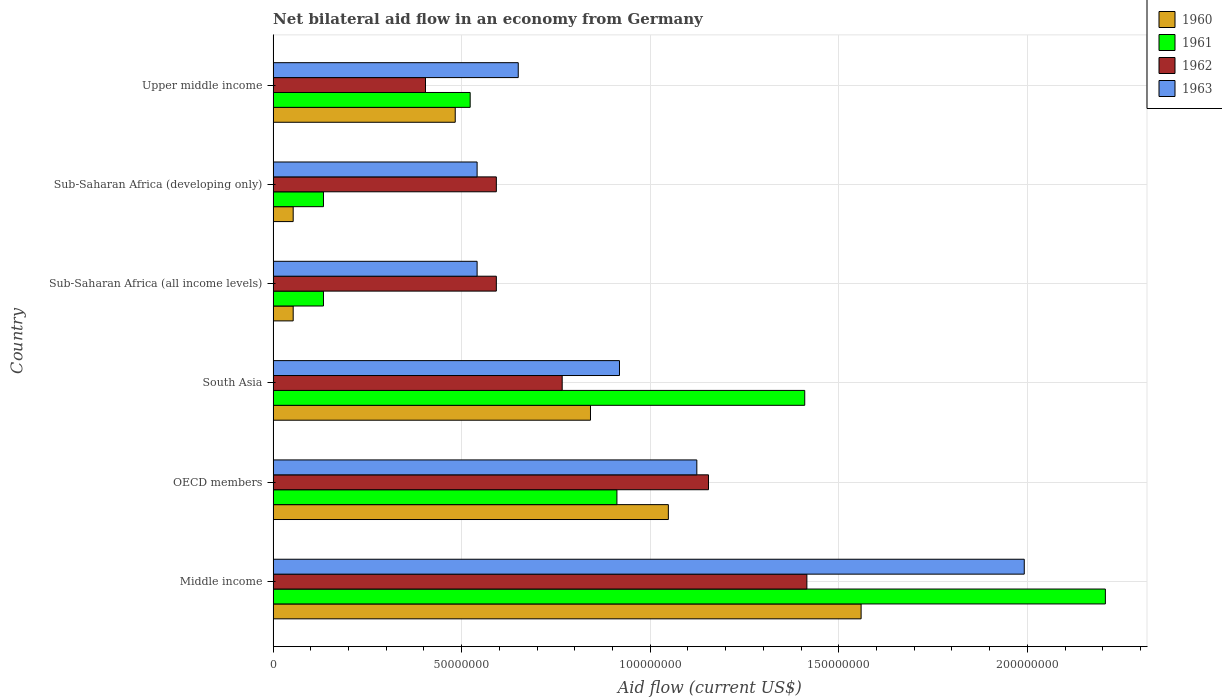How many different coloured bars are there?
Your response must be concise. 4. Are the number of bars per tick equal to the number of legend labels?
Ensure brevity in your answer.  Yes. Are the number of bars on each tick of the Y-axis equal?
Your answer should be compact. Yes. What is the net bilateral aid flow in 1963 in Upper middle income?
Give a very brief answer. 6.50e+07. Across all countries, what is the maximum net bilateral aid flow in 1960?
Your answer should be compact. 1.56e+08. Across all countries, what is the minimum net bilateral aid flow in 1960?
Ensure brevity in your answer.  5.32e+06. In which country was the net bilateral aid flow in 1960 maximum?
Make the answer very short. Middle income. In which country was the net bilateral aid flow in 1961 minimum?
Your answer should be compact. Sub-Saharan Africa (all income levels). What is the total net bilateral aid flow in 1962 in the graph?
Offer a very short reply. 4.92e+08. What is the difference between the net bilateral aid flow in 1960 in Sub-Saharan Africa (all income levels) and that in Sub-Saharan Africa (developing only)?
Offer a very short reply. 0. What is the difference between the net bilateral aid flow in 1963 in Sub-Saharan Africa (developing only) and the net bilateral aid flow in 1962 in Upper middle income?
Offer a very short reply. 1.37e+07. What is the average net bilateral aid flow in 1961 per country?
Make the answer very short. 8.86e+07. What is the difference between the net bilateral aid flow in 1962 and net bilateral aid flow in 1961 in OECD members?
Offer a very short reply. 2.43e+07. In how many countries, is the net bilateral aid flow in 1963 greater than 20000000 US$?
Provide a short and direct response. 6. What is the ratio of the net bilateral aid flow in 1962 in Middle income to that in Upper middle income?
Your answer should be very brief. 3.5. What is the difference between the highest and the second highest net bilateral aid flow in 1962?
Your answer should be very brief. 2.61e+07. What is the difference between the highest and the lowest net bilateral aid flow in 1960?
Your answer should be compact. 1.51e+08. In how many countries, is the net bilateral aid flow in 1962 greater than the average net bilateral aid flow in 1962 taken over all countries?
Your answer should be very brief. 2. Is the sum of the net bilateral aid flow in 1961 in Sub-Saharan Africa (all income levels) and Upper middle income greater than the maximum net bilateral aid flow in 1962 across all countries?
Your answer should be very brief. No. What does the 4th bar from the bottom in OECD members represents?
Provide a short and direct response. 1963. What is the difference between two consecutive major ticks on the X-axis?
Make the answer very short. 5.00e+07. Does the graph contain any zero values?
Offer a very short reply. No. How are the legend labels stacked?
Give a very brief answer. Vertical. What is the title of the graph?
Your response must be concise. Net bilateral aid flow in an economy from Germany. Does "1988" appear as one of the legend labels in the graph?
Your response must be concise. No. What is the Aid flow (current US$) of 1960 in Middle income?
Your response must be concise. 1.56e+08. What is the Aid flow (current US$) of 1961 in Middle income?
Your response must be concise. 2.21e+08. What is the Aid flow (current US$) in 1962 in Middle income?
Keep it short and to the point. 1.42e+08. What is the Aid flow (current US$) in 1963 in Middle income?
Provide a short and direct response. 1.99e+08. What is the Aid flow (current US$) in 1960 in OECD members?
Ensure brevity in your answer.  1.05e+08. What is the Aid flow (current US$) in 1961 in OECD members?
Offer a terse response. 9.12e+07. What is the Aid flow (current US$) of 1962 in OECD members?
Ensure brevity in your answer.  1.15e+08. What is the Aid flow (current US$) of 1963 in OECD members?
Provide a short and direct response. 1.12e+08. What is the Aid flow (current US$) in 1960 in South Asia?
Provide a short and direct response. 8.42e+07. What is the Aid flow (current US$) of 1961 in South Asia?
Your answer should be very brief. 1.41e+08. What is the Aid flow (current US$) in 1962 in South Asia?
Your response must be concise. 7.66e+07. What is the Aid flow (current US$) of 1963 in South Asia?
Give a very brief answer. 9.18e+07. What is the Aid flow (current US$) of 1960 in Sub-Saharan Africa (all income levels)?
Provide a succinct answer. 5.32e+06. What is the Aid flow (current US$) in 1961 in Sub-Saharan Africa (all income levels)?
Give a very brief answer. 1.34e+07. What is the Aid flow (current US$) in 1962 in Sub-Saharan Africa (all income levels)?
Make the answer very short. 5.92e+07. What is the Aid flow (current US$) in 1963 in Sub-Saharan Africa (all income levels)?
Make the answer very short. 5.41e+07. What is the Aid flow (current US$) in 1960 in Sub-Saharan Africa (developing only)?
Make the answer very short. 5.32e+06. What is the Aid flow (current US$) of 1961 in Sub-Saharan Africa (developing only)?
Make the answer very short. 1.34e+07. What is the Aid flow (current US$) in 1962 in Sub-Saharan Africa (developing only)?
Make the answer very short. 5.92e+07. What is the Aid flow (current US$) in 1963 in Sub-Saharan Africa (developing only)?
Offer a terse response. 5.41e+07. What is the Aid flow (current US$) in 1960 in Upper middle income?
Give a very brief answer. 4.83e+07. What is the Aid flow (current US$) in 1961 in Upper middle income?
Give a very brief answer. 5.22e+07. What is the Aid flow (current US$) in 1962 in Upper middle income?
Your response must be concise. 4.04e+07. What is the Aid flow (current US$) of 1963 in Upper middle income?
Offer a very short reply. 6.50e+07. Across all countries, what is the maximum Aid flow (current US$) in 1960?
Make the answer very short. 1.56e+08. Across all countries, what is the maximum Aid flow (current US$) in 1961?
Your answer should be compact. 2.21e+08. Across all countries, what is the maximum Aid flow (current US$) in 1962?
Your answer should be compact. 1.42e+08. Across all countries, what is the maximum Aid flow (current US$) of 1963?
Your answer should be compact. 1.99e+08. Across all countries, what is the minimum Aid flow (current US$) in 1960?
Keep it short and to the point. 5.32e+06. Across all countries, what is the minimum Aid flow (current US$) in 1961?
Offer a very short reply. 1.34e+07. Across all countries, what is the minimum Aid flow (current US$) of 1962?
Make the answer very short. 4.04e+07. Across all countries, what is the minimum Aid flow (current US$) of 1963?
Give a very brief answer. 5.41e+07. What is the total Aid flow (current US$) in 1960 in the graph?
Your answer should be compact. 4.04e+08. What is the total Aid flow (current US$) of 1961 in the graph?
Your response must be concise. 5.32e+08. What is the total Aid flow (current US$) of 1962 in the graph?
Your answer should be compact. 4.92e+08. What is the total Aid flow (current US$) of 1963 in the graph?
Provide a succinct answer. 5.77e+08. What is the difference between the Aid flow (current US$) in 1960 in Middle income and that in OECD members?
Offer a very short reply. 5.11e+07. What is the difference between the Aid flow (current US$) in 1961 in Middle income and that in OECD members?
Your response must be concise. 1.30e+08. What is the difference between the Aid flow (current US$) of 1962 in Middle income and that in OECD members?
Give a very brief answer. 2.61e+07. What is the difference between the Aid flow (current US$) in 1963 in Middle income and that in OECD members?
Provide a succinct answer. 8.68e+07. What is the difference between the Aid flow (current US$) of 1960 in Middle income and that in South Asia?
Keep it short and to the point. 7.18e+07. What is the difference between the Aid flow (current US$) in 1961 in Middle income and that in South Asia?
Ensure brevity in your answer.  7.97e+07. What is the difference between the Aid flow (current US$) in 1962 in Middle income and that in South Asia?
Provide a succinct answer. 6.49e+07. What is the difference between the Aid flow (current US$) in 1963 in Middle income and that in South Asia?
Offer a terse response. 1.07e+08. What is the difference between the Aid flow (current US$) of 1960 in Middle income and that in Sub-Saharan Africa (all income levels)?
Ensure brevity in your answer.  1.51e+08. What is the difference between the Aid flow (current US$) of 1961 in Middle income and that in Sub-Saharan Africa (all income levels)?
Your answer should be compact. 2.07e+08. What is the difference between the Aid flow (current US$) of 1962 in Middle income and that in Sub-Saharan Africa (all income levels)?
Offer a terse response. 8.23e+07. What is the difference between the Aid flow (current US$) in 1963 in Middle income and that in Sub-Saharan Africa (all income levels)?
Offer a terse response. 1.45e+08. What is the difference between the Aid flow (current US$) of 1960 in Middle income and that in Sub-Saharan Africa (developing only)?
Offer a terse response. 1.51e+08. What is the difference between the Aid flow (current US$) in 1961 in Middle income and that in Sub-Saharan Africa (developing only)?
Offer a terse response. 2.07e+08. What is the difference between the Aid flow (current US$) in 1962 in Middle income and that in Sub-Saharan Africa (developing only)?
Provide a short and direct response. 8.23e+07. What is the difference between the Aid flow (current US$) in 1963 in Middle income and that in Sub-Saharan Africa (developing only)?
Keep it short and to the point. 1.45e+08. What is the difference between the Aid flow (current US$) in 1960 in Middle income and that in Upper middle income?
Ensure brevity in your answer.  1.08e+08. What is the difference between the Aid flow (current US$) of 1961 in Middle income and that in Upper middle income?
Your response must be concise. 1.68e+08. What is the difference between the Aid flow (current US$) of 1962 in Middle income and that in Upper middle income?
Your answer should be compact. 1.01e+08. What is the difference between the Aid flow (current US$) of 1963 in Middle income and that in Upper middle income?
Your answer should be very brief. 1.34e+08. What is the difference between the Aid flow (current US$) of 1960 in OECD members and that in South Asia?
Your answer should be very brief. 2.06e+07. What is the difference between the Aid flow (current US$) in 1961 in OECD members and that in South Asia?
Provide a short and direct response. -4.98e+07. What is the difference between the Aid flow (current US$) of 1962 in OECD members and that in South Asia?
Offer a very short reply. 3.88e+07. What is the difference between the Aid flow (current US$) in 1963 in OECD members and that in South Asia?
Your response must be concise. 2.05e+07. What is the difference between the Aid flow (current US$) in 1960 in OECD members and that in Sub-Saharan Africa (all income levels)?
Your answer should be very brief. 9.95e+07. What is the difference between the Aid flow (current US$) of 1961 in OECD members and that in Sub-Saharan Africa (all income levels)?
Offer a terse response. 7.78e+07. What is the difference between the Aid flow (current US$) of 1962 in OECD members and that in Sub-Saharan Africa (all income levels)?
Your answer should be compact. 5.62e+07. What is the difference between the Aid flow (current US$) in 1963 in OECD members and that in Sub-Saharan Africa (all income levels)?
Provide a succinct answer. 5.83e+07. What is the difference between the Aid flow (current US$) of 1960 in OECD members and that in Sub-Saharan Africa (developing only)?
Your response must be concise. 9.95e+07. What is the difference between the Aid flow (current US$) of 1961 in OECD members and that in Sub-Saharan Africa (developing only)?
Provide a short and direct response. 7.78e+07. What is the difference between the Aid flow (current US$) of 1962 in OECD members and that in Sub-Saharan Africa (developing only)?
Provide a short and direct response. 5.62e+07. What is the difference between the Aid flow (current US$) of 1963 in OECD members and that in Sub-Saharan Africa (developing only)?
Keep it short and to the point. 5.83e+07. What is the difference between the Aid flow (current US$) in 1960 in OECD members and that in Upper middle income?
Give a very brief answer. 5.65e+07. What is the difference between the Aid flow (current US$) in 1961 in OECD members and that in Upper middle income?
Your answer should be compact. 3.89e+07. What is the difference between the Aid flow (current US$) in 1962 in OECD members and that in Upper middle income?
Provide a succinct answer. 7.50e+07. What is the difference between the Aid flow (current US$) in 1963 in OECD members and that in Upper middle income?
Your response must be concise. 4.74e+07. What is the difference between the Aid flow (current US$) in 1960 in South Asia and that in Sub-Saharan Africa (all income levels)?
Ensure brevity in your answer.  7.88e+07. What is the difference between the Aid flow (current US$) in 1961 in South Asia and that in Sub-Saharan Africa (all income levels)?
Your response must be concise. 1.28e+08. What is the difference between the Aid flow (current US$) of 1962 in South Asia and that in Sub-Saharan Africa (all income levels)?
Your answer should be compact. 1.75e+07. What is the difference between the Aid flow (current US$) of 1963 in South Asia and that in Sub-Saharan Africa (all income levels)?
Provide a short and direct response. 3.78e+07. What is the difference between the Aid flow (current US$) of 1960 in South Asia and that in Sub-Saharan Africa (developing only)?
Your answer should be compact. 7.88e+07. What is the difference between the Aid flow (current US$) in 1961 in South Asia and that in Sub-Saharan Africa (developing only)?
Your response must be concise. 1.28e+08. What is the difference between the Aid flow (current US$) of 1962 in South Asia and that in Sub-Saharan Africa (developing only)?
Your answer should be compact. 1.75e+07. What is the difference between the Aid flow (current US$) in 1963 in South Asia and that in Sub-Saharan Africa (developing only)?
Offer a terse response. 3.78e+07. What is the difference between the Aid flow (current US$) of 1960 in South Asia and that in Upper middle income?
Give a very brief answer. 3.59e+07. What is the difference between the Aid flow (current US$) of 1961 in South Asia and that in Upper middle income?
Your answer should be very brief. 8.87e+07. What is the difference between the Aid flow (current US$) of 1962 in South Asia and that in Upper middle income?
Offer a very short reply. 3.62e+07. What is the difference between the Aid flow (current US$) in 1963 in South Asia and that in Upper middle income?
Make the answer very short. 2.68e+07. What is the difference between the Aid flow (current US$) of 1960 in Sub-Saharan Africa (all income levels) and that in Sub-Saharan Africa (developing only)?
Offer a terse response. 0. What is the difference between the Aid flow (current US$) in 1961 in Sub-Saharan Africa (all income levels) and that in Sub-Saharan Africa (developing only)?
Your answer should be compact. 0. What is the difference between the Aid flow (current US$) in 1963 in Sub-Saharan Africa (all income levels) and that in Sub-Saharan Africa (developing only)?
Provide a succinct answer. 0. What is the difference between the Aid flow (current US$) of 1960 in Sub-Saharan Africa (all income levels) and that in Upper middle income?
Offer a very short reply. -4.30e+07. What is the difference between the Aid flow (current US$) of 1961 in Sub-Saharan Africa (all income levels) and that in Upper middle income?
Make the answer very short. -3.89e+07. What is the difference between the Aid flow (current US$) in 1962 in Sub-Saharan Africa (all income levels) and that in Upper middle income?
Ensure brevity in your answer.  1.88e+07. What is the difference between the Aid flow (current US$) of 1963 in Sub-Saharan Africa (all income levels) and that in Upper middle income?
Keep it short and to the point. -1.09e+07. What is the difference between the Aid flow (current US$) of 1960 in Sub-Saharan Africa (developing only) and that in Upper middle income?
Keep it short and to the point. -4.30e+07. What is the difference between the Aid flow (current US$) in 1961 in Sub-Saharan Africa (developing only) and that in Upper middle income?
Ensure brevity in your answer.  -3.89e+07. What is the difference between the Aid flow (current US$) of 1962 in Sub-Saharan Africa (developing only) and that in Upper middle income?
Make the answer very short. 1.88e+07. What is the difference between the Aid flow (current US$) of 1963 in Sub-Saharan Africa (developing only) and that in Upper middle income?
Give a very brief answer. -1.09e+07. What is the difference between the Aid flow (current US$) in 1960 in Middle income and the Aid flow (current US$) in 1961 in OECD members?
Provide a succinct answer. 6.48e+07. What is the difference between the Aid flow (current US$) in 1960 in Middle income and the Aid flow (current US$) in 1962 in OECD members?
Your answer should be very brief. 4.05e+07. What is the difference between the Aid flow (current US$) in 1960 in Middle income and the Aid flow (current US$) in 1963 in OECD members?
Offer a very short reply. 4.36e+07. What is the difference between the Aid flow (current US$) in 1961 in Middle income and the Aid flow (current US$) in 1962 in OECD members?
Give a very brief answer. 1.05e+08. What is the difference between the Aid flow (current US$) in 1961 in Middle income and the Aid flow (current US$) in 1963 in OECD members?
Give a very brief answer. 1.08e+08. What is the difference between the Aid flow (current US$) in 1962 in Middle income and the Aid flow (current US$) in 1963 in OECD members?
Give a very brief answer. 2.92e+07. What is the difference between the Aid flow (current US$) in 1960 in Middle income and the Aid flow (current US$) in 1961 in South Asia?
Keep it short and to the point. 1.50e+07. What is the difference between the Aid flow (current US$) in 1960 in Middle income and the Aid flow (current US$) in 1962 in South Asia?
Provide a short and direct response. 7.93e+07. What is the difference between the Aid flow (current US$) of 1960 in Middle income and the Aid flow (current US$) of 1963 in South Asia?
Ensure brevity in your answer.  6.41e+07. What is the difference between the Aid flow (current US$) of 1961 in Middle income and the Aid flow (current US$) of 1962 in South Asia?
Ensure brevity in your answer.  1.44e+08. What is the difference between the Aid flow (current US$) of 1961 in Middle income and the Aid flow (current US$) of 1963 in South Asia?
Keep it short and to the point. 1.29e+08. What is the difference between the Aid flow (current US$) of 1962 in Middle income and the Aid flow (current US$) of 1963 in South Asia?
Your answer should be compact. 4.97e+07. What is the difference between the Aid flow (current US$) of 1960 in Middle income and the Aid flow (current US$) of 1961 in Sub-Saharan Africa (all income levels)?
Keep it short and to the point. 1.43e+08. What is the difference between the Aid flow (current US$) of 1960 in Middle income and the Aid flow (current US$) of 1962 in Sub-Saharan Africa (all income levels)?
Give a very brief answer. 9.67e+07. What is the difference between the Aid flow (current US$) of 1960 in Middle income and the Aid flow (current US$) of 1963 in Sub-Saharan Africa (all income levels)?
Provide a short and direct response. 1.02e+08. What is the difference between the Aid flow (current US$) in 1961 in Middle income and the Aid flow (current US$) in 1962 in Sub-Saharan Africa (all income levels)?
Your response must be concise. 1.61e+08. What is the difference between the Aid flow (current US$) in 1961 in Middle income and the Aid flow (current US$) in 1963 in Sub-Saharan Africa (all income levels)?
Your response must be concise. 1.67e+08. What is the difference between the Aid flow (current US$) in 1962 in Middle income and the Aid flow (current US$) in 1963 in Sub-Saharan Africa (all income levels)?
Make the answer very short. 8.74e+07. What is the difference between the Aid flow (current US$) of 1960 in Middle income and the Aid flow (current US$) of 1961 in Sub-Saharan Africa (developing only)?
Provide a short and direct response. 1.43e+08. What is the difference between the Aid flow (current US$) in 1960 in Middle income and the Aid flow (current US$) in 1962 in Sub-Saharan Africa (developing only)?
Provide a succinct answer. 9.67e+07. What is the difference between the Aid flow (current US$) of 1960 in Middle income and the Aid flow (current US$) of 1963 in Sub-Saharan Africa (developing only)?
Provide a short and direct response. 1.02e+08. What is the difference between the Aid flow (current US$) of 1961 in Middle income and the Aid flow (current US$) of 1962 in Sub-Saharan Africa (developing only)?
Make the answer very short. 1.61e+08. What is the difference between the Aid flow (current US$) of 1961 in Middle income and the Aid flow (current US$) of 1963 in Sub-Saharan Africa (developing only)?
Keep it short and to the point. 1.67e+08. What is the difference between the Aid flow (current US$) in 1962 in Middle income and the Aid flow (current US$) in 1963 in Sub-Saharan Africa (developing only)?
Keep it short and to the point. 8.74e+07. What is the difference between the Aid flow (current US$) in 1960 in Middle income and the Aid flow (current US$) in 1961 in Upper middle income?
Keep it short and to the point. 1.04e+08. What is the difference between the Aid flow (current US$) of 1960 in Middle income and the Aid flow (current US$) of 1962 in Upper middle income?
Provide a short and direct response. 1.16e+08. What is the difference between the Aid flow (current US$) of 1960 in Middle income and the Aid flow (current US$) of 1963 in Upper middle income?
Offer a very short reply. 9.09e+07. What is the difference between the Aid flow (current US$) of 1961 in Middle income and the Aid flow (current US$) of 1962 in Upper middle income?
Provide a short and direct response. 1.80e+08. What is the difference between the Aid flow (current US$) in 1961 in Middle income and the Aid flow (current US$) in 1963 in Upper middle income?
Give a very brief answer. 1.56e+08. What is the difference between the Aid flow (current US$) of 1962 in Middle income and the Aid flow (current US$) of 1963 in Upper middle income?
Provide a succinct answer. 7.65e+07. What is the difference between the Aid flow (current US$) of 1960 in OECD members and the Aid flow (current US$) of 1961 in South Asia?
Ensure brevity in your answer.  -3.62e+07. What is the difference between the Aid flow (current US$) in 1960 in OECD members and the Aid flow (current US$) in 1962 in South Asia?
Your response must be concise. 2.82e+07. What is the difference between the Aid flow (current US$) of 1960 in OECD members and the Aid flow (current US$) of 1963 in South Asia?
Provide a succinct answer. 1.30e+07. What is the difference between the Aid flow (current US$) in 1961 in OECD members and the Aid flow (current US$) in 1962 in South Asia?
Offer a terse response. 1.45e+07. What is the difference between the Aid flow (current US$) of 1961 in OECD members and the Aid flow (current US$) of 1963 in South Asia?
Keep it short and to the point. -6.80e+05. What is the difference between the Aid flow (current US$) in 1962 in OECD members and the Aid flow (current US$) in 1963 in South Asia?
Your answer should be very brief. 2.36e+07. What is the difference between the Aid flow (current US$) of 1960 in OECD members and the Aid flow (current US$) of 1961 in Sub-Saharan Africa (all income levels)?
Give a very brief answer. 9.14e+07. What is the difference between the Aid flow (current US$) of 1960 in OECD members and the Aid flow (current US$) of 1962 in Sub-Saharan Africa (all income levels)?
Your answer should be compact. 4.56e+07. What is the difference between the Aid flow (current US$) in 1960 in OECD members and the Aid flow (current US$) in 1963 in Sub-Saharan Africa (all income levels)?
Ensure brevity in your answer.  5.07e+07. What is the difference between the Aid flow (current US$) in 1961 in OECD members and the Aid flow (current US$) in 1962 in Sub-Saharan Africa (all income levels)?
Offer a terse response. 3.20e+07. What is the difference between the Aid flow (current US$) in 1961 in OECD members and the Aid flow (current US$) in 1963 in Sub-Saharan Africa (all income levels)?
Keep it short and to the point. 3.71e+07. What is the difference between the Aid flow (current US$) of 1962 in OECD members and the Aid flow (current US$) of 1963 in Sub-Saharan Africa (all income levels)?
Offer a terse response. 6.14e+07. What is the difference between the Aid flow (current US$) in 1960 in OECD members and the Aid flow (current US$) in 1961 in Sub-Saharan Africa (developing only)?
Give a very brief answer. 9.14e+07. What is the difference between the Aid flow (current US$) of 1960 in OECD members and the Aid flow (current US$) of 1962 in Sub-Saharan Africa (developing only)?
Your answer should be very brief. 4.56e+07. What is the difference between the Aid flow (current US$) in 1960 in OECD members and the Aid flow (current US$) in 1963 in Sub-Saharan Africa (developing only)?
Your response must be concise. 5.07e+07. What is the difference between the Aid flow (current US$) in 1961 in OECD members and the Aid flow (current US$) in 1962 in Sub-Saharan Africa (developing only)?
Keep it short and to the point. 3.20e+07. What is the difference between the Aid flow (current US$) of 1961 in OECD members and the Aid flow (current US$) of 1963 in Sub-Saharan Africa (developing only)?
Ensure brevity in your answer.  3.71e+07. What is the difference between the Aid flow (current US$) of 1962 in OECD members and the Aid flow (current US$) of 1963 in Sub-Saharan Africa (developing only)?
Provide a short and direct response. 6.14e+07. What is the difference between the Aid flow (current US$) of 1960 in OECD members and the Aid flow (current US$) of 1961 in Upper middle income?
Your answer should be compact. 5.26e+07. What is the difference between the Aid flow (current US$) in 1960 in OECD members and the Aid flow (current US$) in 1962 in Upper middle income?
Your answer should be very brief. 6.44e+07. What is the difference between the Aid flow (current US$) in 1960 in OECD members and the Aid flow (current US$) in 1963 in Upper middle income?
Offer a terse response. 3.98e+07. What is the difference between the Aid flow (current US$) of 1961 in OECD members and the Aid flow (current US$) of 1962 in Upper middle income?
Give a very brief answer. 5.08e+07. What is the difference between the Aid flow (current US$) of 1961 in OECD members and the Aid flow (current US$) of 1963 in Upper middle income?
Provide a succinct answer. 2.62e+07. What is the difference between the Aid flow (current US$) of 1962 in OECD members and the Aid flow (current US$) of 1963 in Upper middle income?
Offer a terse response. 5.04e+07. What is the difference between the Aid flow (current US$) in 1960 in South Asia and the Aid flow (current US$) in 1961 in Sub-Saharan Africa (all income levels)?
Offer a terse response. 7.08e+07. What is the difference between the Aid flow (current US$) of 1960 in South Asia and the Aid flow (current US$) of 1962 in Sub-Saharan Africa (all income levels)?
Your response must be concise. 2.50e+07. What is the difference between the Aid flow (current US$) of 1960 in South Asia and the Aid flow (current US$) of 1963 in Sub-Saharan Africa (all income levels)?
Your response must be concise. 3.01e+07. What is the difference between the Aid flow (current US$) of 1961 in South Asia and the Aid flow (current US$) of 1962 in Sub-Saharan Africa (all income levels)?
Provide a succinct answer. 8.18e+07. What is the difference between the Aid flow (current US$) in 1961 in South Asia and the Aid flow (current US$) in 1963 in Sub-Saharan Africa (all income levels)?
Provide a succinct answer. 8.69e+07. What is the difference between the Aid flow (current US$) of 1962 in South Asia and the Aid flow (current US$) of 1963 in Sub-Saharan Africa (all income levels)?
Provide a succinct answer. 2.26e+07. What is the difference between the Aid flow (current US$) in 1960 in South Asia and the Aid flow (current US$) in 1961 in Sub-Saharan Africa (developing only)?
Offer a very short reply. 7.08e+07. What is the difference between the Aid flow (current US$) in 1960 in South Asia and the Aid flow (current US$) in 1962 in Sub-Saharan Africa (developing only)?
Your response must be concise. 2.50e+07. What is the difference between the Aid flow (current US$) in 1960 in South Asia and the Aid flow (current US$) in 1963 in Sub-Saharan Africa (developing only)?
Keep it short and to the point. 3.01e+07. What is the difference between the Aid flow (current US$) of 1961 in South Asia and the Aid flow (current US$) of 1962 in Sub-Saharan Africa (developing only)?
Your answer should be compact. 8.18e+07. What is the difference between the Aid flow (current US$) in 1961 in South Asia and the Aid flow (current US$) in 1963 in Sub-Saharan Africa (developing only)?
Offer a very short reply. 8.69e+07. What is the difference between the Aid flow (current US$) in 1962 in South Asia and the Aid flow (current US$) in 1963 in Sub-Saharan Africa (developing only)?
Ensure brevity in your answer.  2.26e+07. What is the difference between the Aid flow (current US$) of 1960 in South Asia and the Aid flow (current US$) of 1961 in Upper middle income?
Provide a short and direct response. 3.19e+07. What is the difference between the Aid flow (current US$) of 1960 in South Asia and the Aid flow (current US$) of 1962 in Upper middle income?
Provide a succinct answer. 4.38e+07. What is the difference between the Aid flow (current US$) of 1960 in South Asia and the Aid flow (current US$) of 1963 in Upper middle income?
Your response must be concise. 1.92e+07. What is the difference between the Aid flow (current US$) of 1961 in South Asia and the Aid flow (current US$) of 1962 in Upper middle income?
Your answer should be very brief. 1.01e+08. What is the difference between the Aid flow (current US$) in 1961 in South Asia and the Aid flow (current US$) in 1963 in Upper middle income?
Your answer should be compact. 7.60e+07. What is the difference between the Aid flow (current US$) of 1962 in South Asia and the Aid flow (current US$) of 1963 in Upper middle income?
Give a very brief answer. 1.16e+07. What is the difference between the Aid flow (current US$) of 1960 in Sub-Saharan Africa (all income levels) and the Aid flow (current US$) of 1961 in Sub-Saharan Africa (developing only)?
Offer a very short reply. -8.03e+06. What is the difference between the Aid flow (current US$) of 1960 in Sub-Saharan Africa (all income levels) and the Aid flow (current US$) of 1962 in Sub-Saharan Africa (developing only)?
Give a very brief answer. -5.39e+07. What is the difference between the Aid flow (current US$) of 1960 in Sub-Saharan Africa (all income levels) and the Aid flow (current US$) of 1963 in Sub-Saharan Africa (developing only)?
Your response must be concise. -4.88e+07. What is the difference between the Aid flow (current US$) of 1961 in Sub-Saharan Africa (all income levels) and the Aid flow (current US$) of 1962 in Sub-Saharan Africa (developing only)?
Provide a succinct answer. -4.58e+07. What is the difference between the Aid flow (current US$) of 1961 in Sub-Saharan Africa (all income levels) and the Aid flow (current US$) of 1963 in Sub-Saharan Africa (developing only)?
Offer a terse response. -4.07e+07. What is the difference between the Aid flow (current US$) of 1962 in Sub-Saharan Africa (all income levels) and the Aid flow (current US$) of 1963 in Sub-Saharan Africa (developing only)?
Give a very brief answer. 5.10e+06. What is the difference between the Aid flow (current US$) of 1960 in Sub-Saharan Africa (all income levels) and the Aid flow (current US$) of 1961 in Upper middle income?
Provide a succinct answer. -4.69e+07. What is the difference between the Aid flow (current US$) in 1960 in Sub-Saharan Africa (all income levels) and the Aid flow (current US$) in 1962 in Upper middle income?
Provide a short and direct response. -3.51e+07. What is the difference between the Aid flow (current US$) of 1960 in Sub-Saharan Africa (all income levels) and the Aid flow (current US$) of 1963 in Upper middle income?
Your answer should be very brief. -5.97e+07. What is the difference between the Aid flow (current US$) in 1961 in Sub-Saharan Africa (all income levels) and the Aid flow (current US$) in 1962 in Upper middle income?
Provide a succinct answer. -2.70e+07. What is the difference between the Aid flow (current US$) of 1961 in Sub-Saharan Africa (all income levels) and the Aid flow (current US$) of 1963 in Upper middle income?
Your response must be concise. -5.16e+07. What is the difference between the Aid flow (current US$) in 1962 in Sub-Saharan Africa (all income levels) and the Aid flow (current US$) in 1963 in Upper middle income?
Your response must be concise. -5.81e+06. What is the difference between the Aid flow (current US$) in 1960 in Sub-Saharan Africa (developing only) and the Aid flow (current US$) in 1961 in Upper middle income?
Your answer should be very brief. -4.69e+07. What is the difference between the Aid flow (current US$) in 1960 in Sub-Saharan Africa (developing only) and the Aid flow (current US$) in 1962 in Upper middle income?
Provide a short and direct response. -3.51e+07. What is the difference between the Aid flow (current US$) in 1960 in Sub-Saharan Africa (developing only) and the Aid flow (current US$) in 1963 in Upper middle income?
Your response must be concise. -5.97e+07. What is the difference between the Aid flow (current US$) in 1961 in Sub-Saharan Africa (developing only) and the Aid flow (current US$) in 1962 in Upper middle income?
Your response must be concise. -2.70e+07. What is the difference between the Aid flow (current US$) in 1961 in Sub-Saharan Africa (developing only) and the Aid flow (current US$) in 1963 in Upper middle income?
Provide a succinct answer. -5.16e+07. What is the difference between the Aid flow (current US$) of 1962 in Sub-Saharan Africa (developing only) and the Aid flow (current US$) of 1963 in Upper middle income?
Your answer should be very brief. -5.81e+06. What is the average Aid flow (current US$) in 1960 per country?
Provide a short and direct response. 6.73e+07. What is the average Aid flow (current US$) in 1961 per country?
Your answer should be very brief. 8.86e+07. What is the average Aid flow (current US$) in 1962 per country?
Provide a short and direct response. 8.21e+07. What is the average Aid flow (current US$) of 1963 per country?
Ensure brevity in your answer.  9.61e+07. What is the difference between the Aid flow (current US$) in 1960 and Aid flow (current US$) in 1961 in Middle income?
Your answer should be compact. -6.48e+07. What is the difference between the Aid flow (current US$) of 1960 and Aid flow (current US$) of 1962 in Middle income?
Provide a short and direct response. 1.44e+07. What is the difference between the Aid flow (current US$) of 1960 and Aid flow (current US$) of 1963 in Middle income?
Your answer should be compact. -4.33e+07. What is the difference between the Aid flow (current US$) of 1961 and Aid flow (current US$) of 1962 in Middle income?
Provide a short and direct response. 7.92e+07. What is the difference between the Aid flow (current US$) in 1961 and Aid flow (current US$) in 1963 in Middle income?
Give a very brief answer. 2.15e+07. What is the difference between the Aid flow (current US$) of 1962 and Aid flow (current US$) of 1963 in Middle income?
Offer a very short reply. -5.76e+07. What is the difference between the Aid flow (current US$) of 1960 and Aid flow (current US$) of 1961 in OECD members?
Provide a succinct answer. 1.36e+07. What is the difference between the Aid flow (current US$) of 1960 and Aid flow (current US$) of 1962 in OECD members?
Your answer should be compact. -1.06e+07. What is the difference between the Aid flow (current US$) in 1960 and Aid flow (current US$) in 1963 in OECD members?
Provide a succinct answer. -7.55e+06. What is the difference between the Aid flow (current US$) in 1961 and Aid flow (current US$) in 1962 in OECD members?
Your answer should be compact. -2.43e+07. What is the difference between the Aid flow (current US$) in 1961 and Aid flow (current US$) in 1963 in OECD members?
Your response must be concise. -2.12e+07. What is the difference between the Aid flow (current US$) in 1962 and Aid flow (current US$) in 1963 in OECD members?
Your response must be concise. 3.09e+06. What is the difference between the Aid flow (current US$) of 1960 and Aid flow (current US$) of 1961 in South Asia?
Your answer should be very brief. -5.68e+07. What is the difference between the Aid flow (current US$) of 1960 and Aid flow (current US$) of 1962 in South Asia?
Keep it short and to the point. 7.50e+06. What is the difference between the Aid flow (current US$) in 1960 and Aid flow (current US$) in 1963 in South Asia?
Ensure brevity in your answer.  -7.69e+06. What is the difference between the Aid flow (current US$) of 1961 and Aid flow (current US$) of 1962 in South Asia?
Your answer should be compact. 6.43e+07. What is the difference between the Aid flow (current US$) of 1961 and Aid flow (current US$) of 1963 in South Asia?
Offer a terse response. 4.91e+07. What is the difference between the Aid flow (current US$) in 1962 and Aid flow (current US$) in 1963 in South Asia?
Provide a short and direct response. -1.52e+07. What is the difference between the Aid flow (current US$) of 1960 and Aid flow (current US$) of 1961 in Sub-Saharan Africa (all income levels)?
Offer a terse response. -8.03e+06. What is the difference between the Aid flow (current US$) of 1960 and Aid flow (current US$) of 1962 in Sub-Saharan Africa (all income levels)?
Offer a very short reply. -5.39e+07. What is the difference between the Aid flow (current US$) of 1960 and Aid flow (current US$) of 1963 in Sub-Saharan Africa (all income levels)?
Your answer should be very brief. -4.88e+07. What is the difference between the Aid flow (current US$) in 1961 and Aid flow (current US$) in 1962 in Sub-Saharan Africa (all income levels)?
Provide a short and direct response. -4.58e+07. What is the difference between the Aid flow (current US$) of 1961 and Aid flow (current US$) of 1963 in Sub-Saharan Africa (all income levels)?
Provide a succinct answer. -4.07e+07. What is the difference between the Aid flow (current US$) of 1962 and Aid flow (current US$) of 1963 in Sub-Saharan Africa (all income levels)?
Your response must be concise. 5.10e+06. What is the difference between the Aid flow (current US$) in 1960 and Aid flow (current US$) in 1961 in Sub-Saharan Africa (developing only)?
Offer a terse response. -8.03e+06. What is the difference between the Aid flow (current US$) of 1960 and Aid flow (current US$) of 1962 in Sub-Saharan Africa (developing only)?
Your response must be concise. -5.39e+07. What is the difference between the Aid flow (current US$) in 1960 and Aid flow (current US$) in 1963 in Sub-Saharan Africa (developing only)?
Keep it short and to the point. -4.88e+07. What is the difference between the Aid flow (current US$) of 1961 and Aid flow (current US$) of 1962 in Sub-Saharan Africa (developing only)?
Provide a short and direct response. -4.58e+07. What is the difference between the Aid flow (current US$) of 1961 and Aid flow (current US$) of 1963 in Sub-Saharan Africa (developing only)?
Your answer should be very brief. -4.07e+07. What is the difference between the Aid flow (current US$) in 1962 and Aid flow (current US$) in 1963 in Sub-Saharan Africa (developing only)?
Offer a very short reply. 5.10e+06. What is the difference between the Aid flow (current US$) of 1960 and Aid flow (current US$) of 1961 in Upper middle income?
Give a very brief answer. -3.96e+06. What is the difference between the Aid flow (current US$) of 1960 and Aid flow (current US$) of 1962 in Upper middle income?
Provide a short and direct response. 7.89e+06. What is the difference between the Aid flow (current US$) in 1960 and Aid flow (current US$) in 1963 in Upper middle income?
Your answer should be compact. -1.67e+07. What is the difference between the Aid flow (current US$) in 1961 and Aid flow (current US$) in 1962 in Upper middle income?
Offer a terse response. 1.18e+07. What is the difference between the Aid flow (current US$) in 1961 and Aid flow (current US$) in 1963 in Upper middle income?
Provide a short and direct response. -1.28e+07. What is the difference between the Aid flow (current US$) of 1962 and Aid flow (current US$) of 1963 in Upper middle income?
Your answer should be very brief. -2.46e+07. What is the ratio of the Aid flow (current US$) in 1960 in Middle income to that in OECD members?
Your response must be concise. 1.49. What is the ratio of the Aid flow (current US$) of 1961 in Middle income to that in OECD members?
Your response must be concise. 2.42. What is the ratio of the Aid flow (current US$) in 1962 in Middle income to that in OECD members?
Your answer should be very brief. 1.23. What is the ratio of the Aid flow (current US$) of 1963 in Middle income to that in OECD members?
Keep it short and to the point. 1.77. What is the ratio of the Aid flow (current US$) of 1960 in Middle income to that in South Asia?
Give a very brief answer. 1.85. What is the ratio of the Aid flow (current US$) in 1961 in Middle income to that in South Asia?
Keep it short and to the point. 1.57. What is the ratio of the Aid flow (current US$) in 1962 in Middle income to that in South Asia?
Give a very brief answer. 1.85. What is the ratio of the Aid flow (current US$) of 1963 in Middle income to that in South Asia?
Keep it short and to the point. 2.17. What is the ratio of the Aid flow (current US$) of 1960 in Middle income to that in Sub-Saharan Africa (all income levels)?
Provide a succinct answer. 29.31. What is the ratio of the Aid flow (current US$) of 1961 in Middle income to that in Sub-Saharan Africa (all income levels)?
Ensure brevity in your answer.  16.53. What is the ratio of the Aid flow (current US$) in 1962 in Middle income to that in Sub-Saharan Africa (all income levels)?
Provide a short and direct response. 2.39. What is the ratio of the Aid flow (current US$) of 1963 in Middle income to that in Sub-Saharan Africa (all income levels)?
Give a very brief answer. 3.68. What is the ratio of the Aid flow (current US$) in 1960 in Middle income to that in Sub-Saharan Africa (developing only)?
Provide a short and direct response. 29.31. What is the ratio of the Aid flow (current US$) in 1961 in Middle income to that in Sub-Saharan Africa (developing only)?
Provide a short and direct response. 16.53. What is the ratio of the Aid flow (current US$) in 1962 in Middle income to that in Sub-Saharan Africa (developing only)?
Provide a succinct answer. 2.39. What is the ratio of the Aid flow (current US$) in 1963 in Middle income to that in Sub-Saharan Africa (developing only)?
Your answer should be compact. 3.68. What is the ratio of the Aid flow (current US$) of 1960 in Middle income to that in Upper middle income?
Your answer should be very brief. 3.23. What is the ratio of the Aid flow (current US$) of 1961 in Middle income to that in Upper middle income?
Ensure brevity in your answer.  4.22. What is the ratio of the Aid flow (current US$) in 1962 in Middle income to that in Upper middle income?
Ensure brevity in your answer.  3.5. What is the ratio of the Aid flow (current US$) in 1963 in Middle income to that in Upper middle income?
Provide a short and direct response. 3.06. What is the ratio of the Aid flow (current US$) of 1960 in OECD members to that in South Asia?
Your response must be concise. 1.25. What is the ratio of the Aid flow (current US$) of 1961 in OECD members to that in South Asia?
Offer a terse response. 0.65. What is the ratio of the Aid flow (current US$) in 1962 in OECD members to that in South Asia?
Your response must be concise. 1.51. What is the ratio of the Aid flow (current US$) in 1963 in OECD members to that in South Asia?
Your answer should be compact. 1.22. What is the ratio of the Aid flow (current US$) of 1960 in OECD members to that in Sub-Saharan Africa (all income levels)?
Offer a very short reply. 19.7. What is the ratio of the Aid flow (current US$) of 1961 in OECD members to that in Sub-Saharan Africa (all income levels)?
Your response must be concise. 6.83. What is the ratio of the Aid flow (current US$) of 1962 in OECD members to that in Sub-Saharan Africa (all income levels)?
Make the answer very short. 1.95. What is the ratio of the Aid flow (current US$) of 1963 in OECD members to that in Sub-Saharan Africa (all income levels)?
Make the answer very short. 2.08. What is the ratio of the Aid flow (current US$) of 1960 in OECD members to that in Sub-Saharan Africa (developing only)?
Provide a succinct answer. 19.7. What is the ratio of the Aid flow (current US$) in 1961 in OECD members to that in Sub-Saharan Africa (developing only)?
Offer a terse response. 6.83. What is the ratio of the Aid flow (current US$) of 1962 in OECD members to that in Sub-Saharan Africa (developing only)?
Your response must be concise. 1.95. What is the ratio of the Aid flow (current US$) in 1963 in OECD members to that in Sub-Saharan Africa (developing only)?
Provide a short and direct response. 2.08. What is the ratio of the Aid flow (current US$) in 1960 in OECD members to that in Upper middle income?
Give a very brief answer. 2.17. What is the ratio of the Aid flow (current US$) in 1961 in OECD members to that in Upper middle income?
Make the answer very short. 1.74. What is the ratio of the Aid flow (current US$) in 1962 in OECD members to that in Upper middle income?
Ensure brevity in your answer.  2.86. What is the ratio of the Aid flow (current US$) of 1963 in OECD members to that in Upper middle income?
Your answer should be compact. 1.73. What is the ratio of the Aid flow (current US$) of 1960 in South Asia to that in Sub-Saharan Africa (all income levels)?
Your response must be concise. 15.82. What is the ratio of the Aid flow (current US$) in 1961 in South Asia to that in Sub-Saharan Africa (all income levels)?
Your answer should be compact. 10.56. What is the ratio of the Aid flow (current US$) of 1962 in South Asia to that in Sub-Saharan Africa (all income levels)?
Ensure brevity in your answer.  1.29. What is the ratio of the Aid flow (current US$) in 1963 in South Asia to that in Sub-Saharan Africa (all income levels)?
Your response must be concise. 1.7. What is the ratio of the Aid flow (current US$) in 1960 in South Asia to that in Sub-Saharan Africa (developing only)?
Your answer should be compact. 15.82. What is the ratio of the Aid flow (current US$) in 1961 in South Asia to that in Sub-Saharan Africa (developing only)?
Give a very brief answer. 10.56. What is the ratio of the Aid flow (current US$) in 1962 in South Asia to that in Sub-Saharan Africa (developing only)?
Offer a very short reply. 1.29. What is the ratio of the Aid flow (current US$) of 1963 in South Asia to that in Sub-Saharan Africa (developing only)?
Provide a short and direct response. 1.7. What is the ratio of the Aid flow (current US$) of 1960 in South Asia to that in Upper middle income?
Offer a terse response. 1.74. What is the ratio of the Aid flow (current US$) of 1961 in South Asia to that in Upper middle income?
Your response must be concise. 2.7. What is the ratio of the Aid flow (current US$) of 1962 in South Asia to that in Upper middle income?
Provide a short and direct response. 1.9. What is the ratio of the Aid flow (current US$) in 1963 in South Asia to that in Upper middle income?
Provide a succinct answer. 1.41. What is the ratio of the Aid flow (current US$) of 1960 in Sub-Saharan Africa (all income levels) to that in Sub-Saharan Africa (developing only)?
Offer a terse response. 1. What is the ratio of the Aid flow (current US$) in 1961 in Sub-Saharan Africa (all income levels) to that in Sub-Saharan Africa (developing only)?
Keep it short and to the point. 1. What is the ratio of the Aid flow (current US$) of 1960 in Sub-Saharan Africa (all income levels) to that in Upper middle income?
Keep it short and to the point. 0.11. What is the ratio of the Aid flow (current US$) of 1961 in Sub-Saharan Africa (all income levels) to that in Upper middle income?
Provide a succinct answer. 0.26. What is the ratio of the Aid flow (current US$) in 1962 in Sub-Saharan Africa (all income levels) to that in Upper middle income?
Provide a succinct answer. 1.47. What is the ratio of the Aid flow (current US$) of 1963 in Sub-Saharan Africa (all income levels) to that in Upper middle income?
Make the answer very short. 0.83. What is the ratio of the Aid flow (current US$) of 1960 in Sub-Saharan Africa (developing only) to that in Upper middle income?
Your answer should be very brief. 0.11. What is the ratio of the Aid flow (current US$) of 1961 in Sub-Saharan Africa (developing only) to that in Upper middle income?
Your answer should be compact. 0.26. What is the ratio of the Aid flow (current US$) in 1962 in Sub-Saharan Africa (developing only) to that in Upper middle income?
Provide a succinct answer. 1.47. What is the ratio of the Aid flow (current US$) of 1963 in Sub-Saharan Africa (developing only) to that in Upper middle income?
Offer a very short reply. 0.83. What is the difference between the highest and the second highest Aid flow (current US$) in 1960?
Provide a short and direct response. 5.11e+07. What is the difference between the highest and the second highest Aid flow (current US$) of 1961?
Your answer should be compact. 7.97e+07. What is the difference between the highest and the second highest Aid flow (current US$) of 1962?
Give a very brief answer. 2.61e+07. What is the difference between the highest and the second highest Aid flow (current US$) in 1963?
Your answer should be very brief. 8.68e+07. What is the difference between the highest and the lowest Aid flow (current US$) in 1960?
Give a very brief answer. 1.51e+08. What is the difference between the highest and the lowest Aid flow (current US$) of 1961?
Your answer should be compact. 2.07e+08. What is the difference between the highest and the lowest Aid flow (current US$) in 1962?
Give a very brief answer. 1.01e+08. What is the difference between the highest and the lowest Aid flow (current US$) of 1963?
Give a very brief answer. 1.45e+08. 